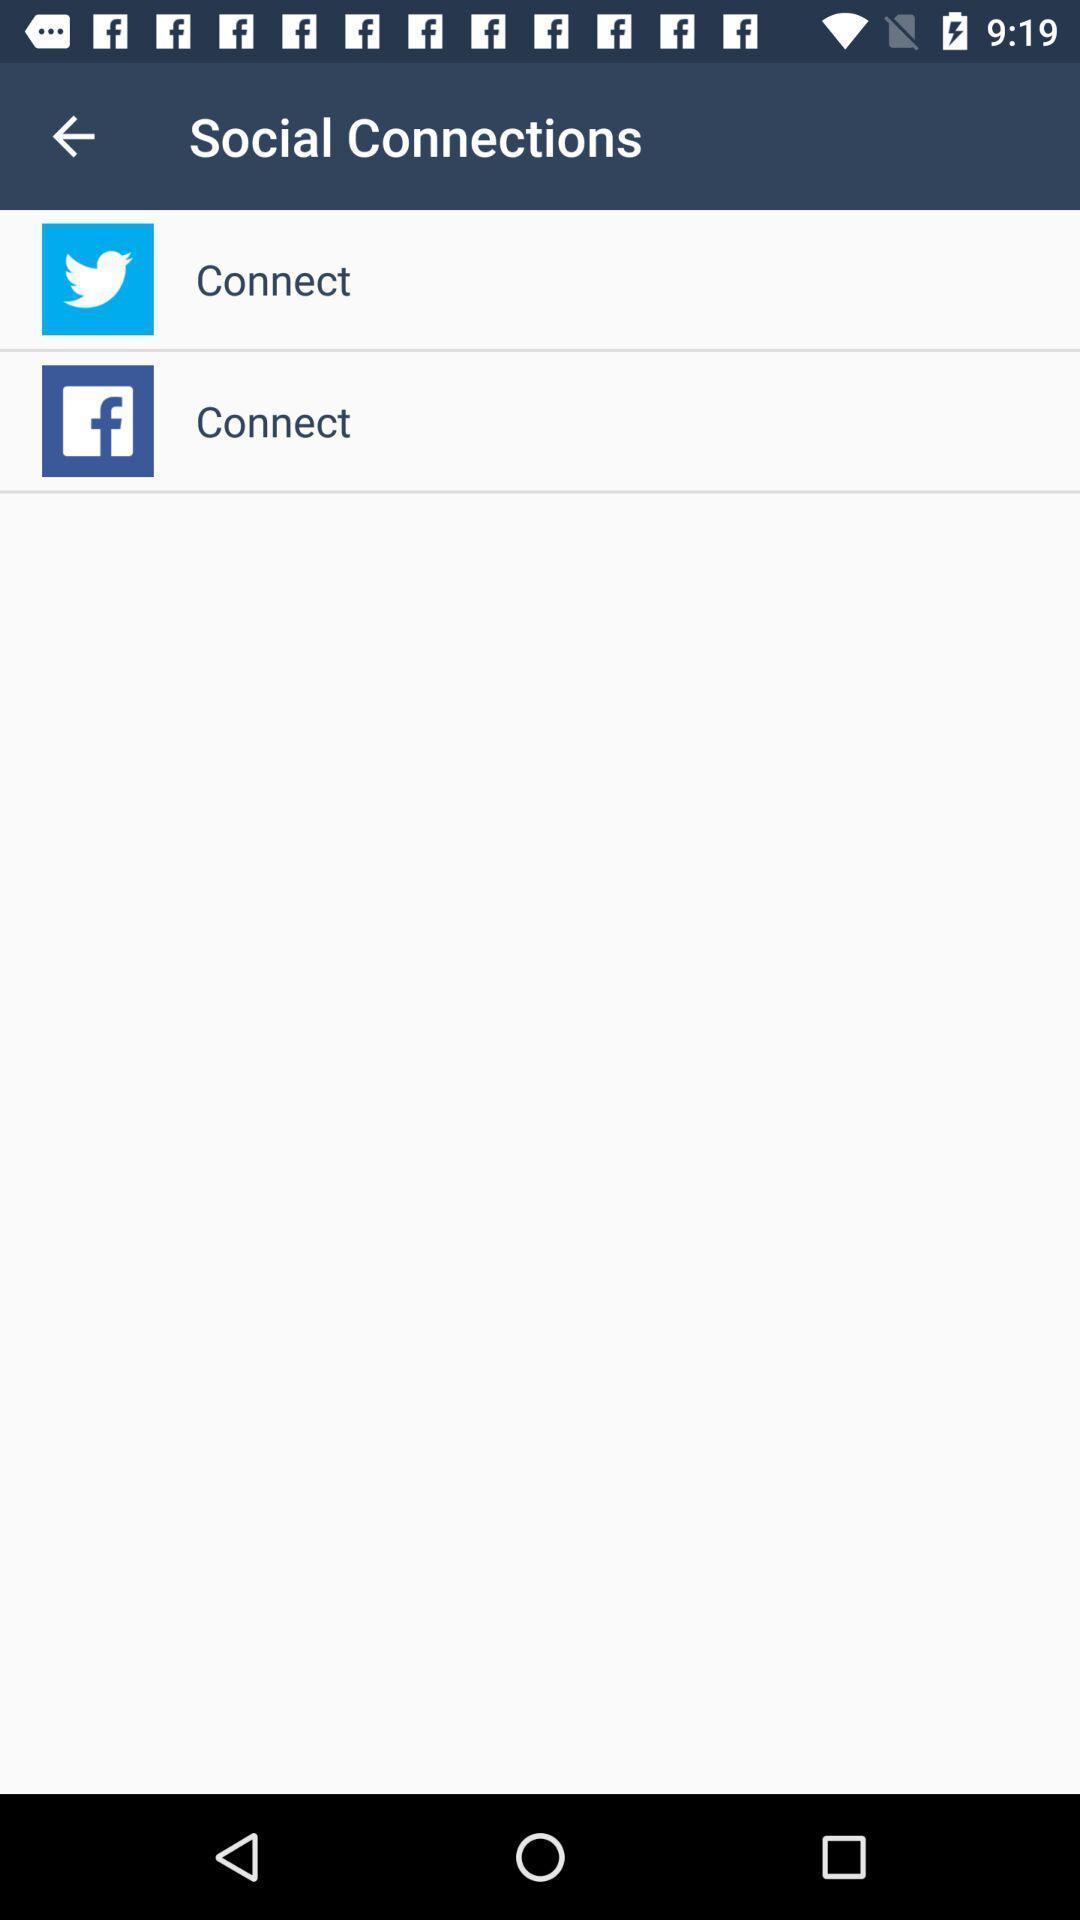Provide a detailed account of this screenshot. Screen showing two applications to connect. 